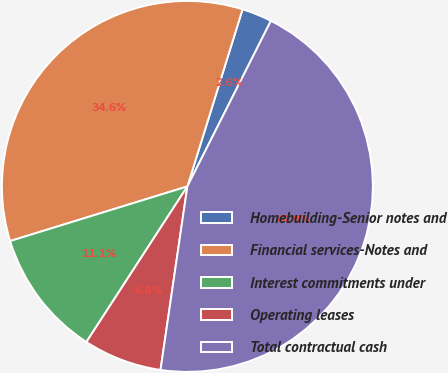Convert chart. <chart><loc_0><loc_0><loc_500><loc_500><pie_chart><fcel>Homebuilding-Senior notes and<fcel>Financial services-Notes and<fcel>Interest commitments under<fcel>Operating leases<fcel>Total contractual cash<nl><fcel>2.63%<fcel>34.57%<fcel>11.08%<fcel>6.85%<fcel>44.88%<nl></chart> 